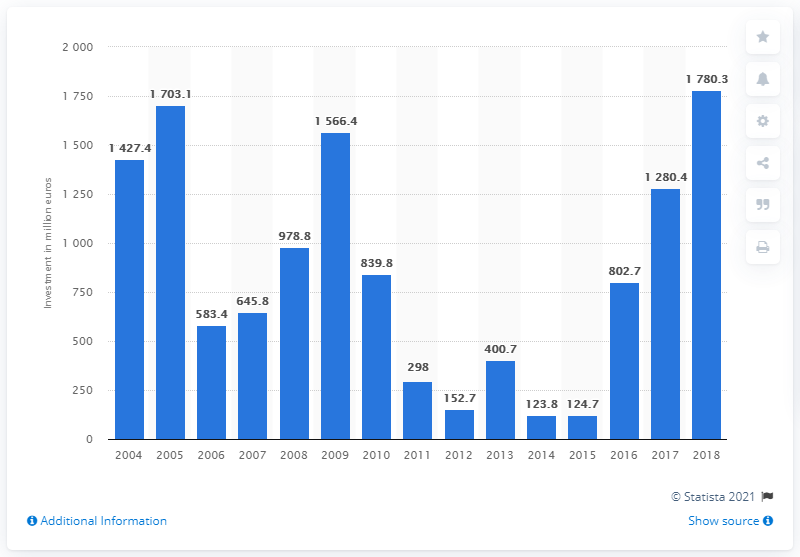List a handful of essential elements in this visual. In 2018, the largest amount of money was invested in road network infrastructure. 